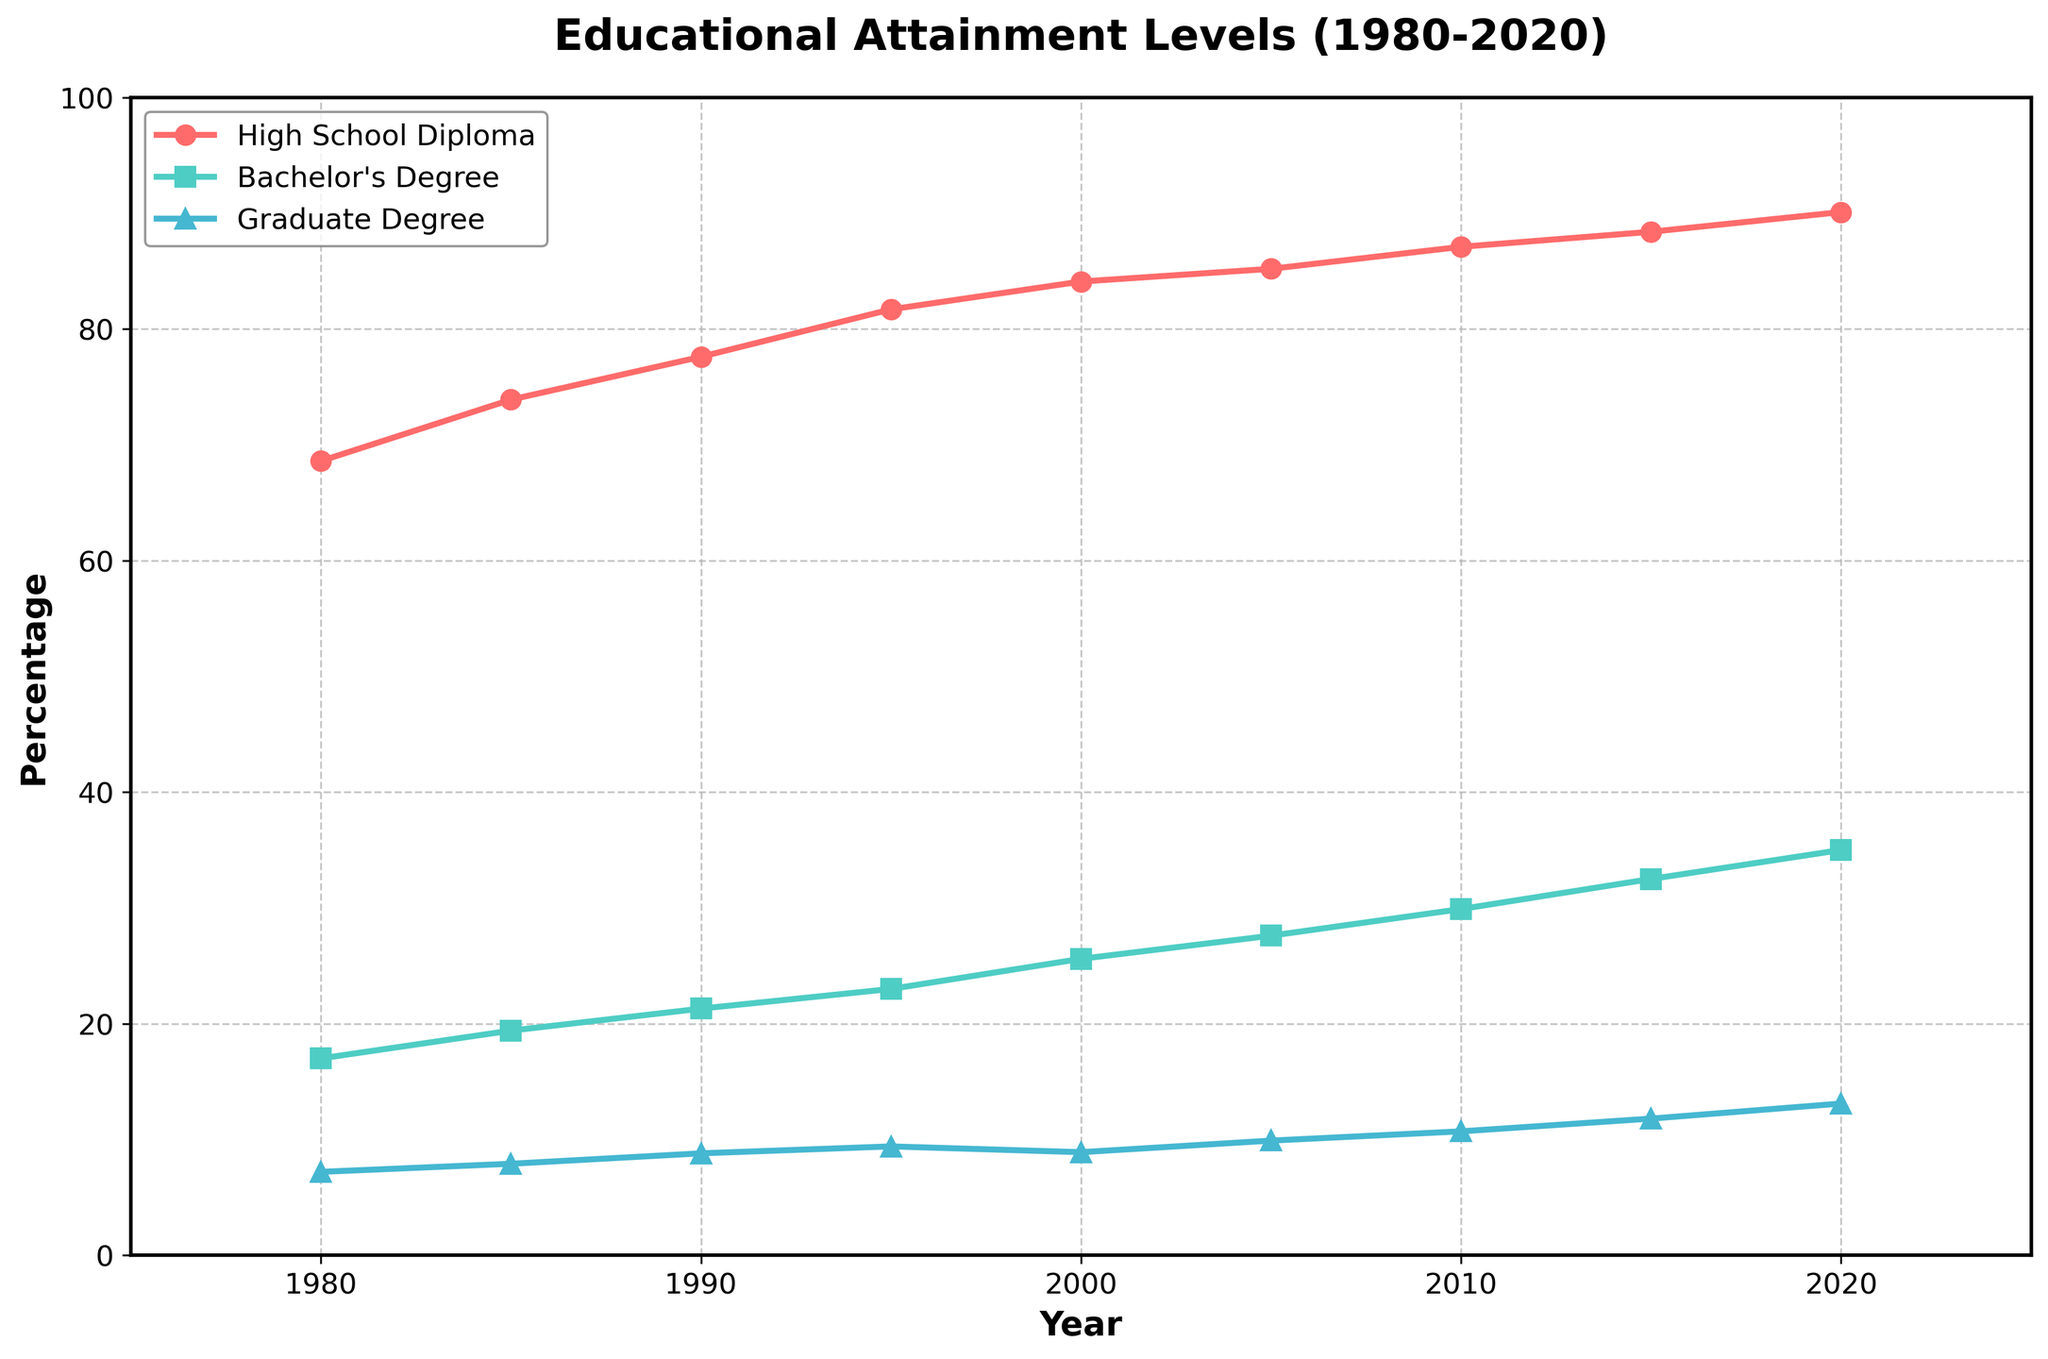What is the overall trend of high school diploma attainment from 1980 to 2020? The high school diploma attainment percentage has a continuous increasing trend from 68.6% in 1980 to 90.1% in 2020.
Answer: Increasing Between 2000 and 2020, how much did the percentage of the population with a bachelor's degree increase? The percentage of the population with a bachelor's degree was 25.6% in 2000 and increased to 35.0% in 2020, so the difference is 35.0% - 25.6% = 9.4%.
Answer: 9.4% Which educational attainment category had the smallest increase over the 40-year period? High school diploma increased from 68.6% to 90.1% (21.5% increase), bachelor's degree increased from 17.0% to 35.0% (18.0% increase), and graduate degree increased from 7.2% to 13.1% (5.9% increase). The smallest increase is in graduate degrees.
Answer: Graduate Degree In what year did the percentage of the population with a bachelor's degree surpass 30%? The percentage of the population with a bachelor's degree first surpassed 30% in the year 2015.
Answer: 2015 How does the increase in high school diploma attainment compare to the increase in bachelor's degree attainment from 1980 to 2020? The increase in high school diploma attainment from 1980 to 2020 is 90.1% - 68.6% = 21.5%. The increase in bachelor's degree attainment in the same period is 35.0% - 17.0% = 18.0%. The increase is larger for high school diplomas.
Answer: High school diploma increase is larger What was the highest percentage of the population with a graduate degree recorded in the data? The highest percentage of the population with a graduate degree in the data was 13.1% in 2020.
Answer: 13.1% How did the percentage of the population with a high school diploma change between 1985 and 2005? The percentage of the population with a high school diploma was 73.9% in 1985 and increased to 85.2% in 2005, so the change is 85.2% - 73.9% = 11.3%.
Answer: 11.3% In which year did the percentage of the working-age population with a graduate degree first exceed 10%? The percentage of the working-age population with a graduate degree first exceeded 10% in the year 2010.
Answer: 2010 